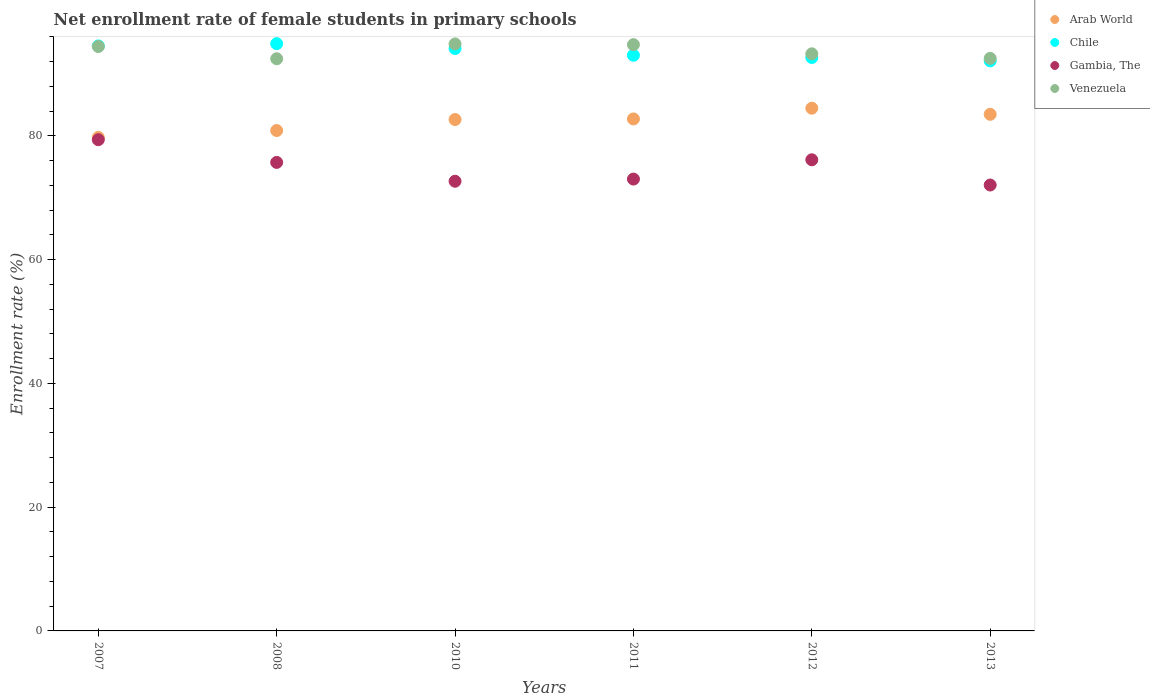How many different coloured dotlines are there?
Ensure brevity in your answer.  4. What is the net enrollment rate of female students in primary schools in Gambia, The in 2013?
Make the answer very short. 72.06. Across all years, what is the maximum net enrollment rate of female students in primary schools in Arab World?
Offer a very short reply. 84.48. Across all years, what is the minimum net enrollment rate of female students in primary schools in Arab World?
Ensure brevity in your answer.  79.76. What is the total net enrollment rate of female students in primary schools in Arab World in the graph?
Provide a short and direct response. 493.98. What is the difference between the net enrollment rate of female students in primary schools in Chile in 2011 and that in 2013?
Provide a succinct answer. 0.91. What is the difference between the net enrollment rate of female students in primary schools in Venezuela in 2011 and the net enrollment rate of female students in primary schools in Chile in 2012?
Your answer should be compact. 2.07. What is the average net enrollment rate of female students in primary schools in Venezuela per year?
Provide a short and direct response. 93.72. In the year 2011, what is the difference between the net enrollment rate of female students in primary schools in Arab World and net enrollment rate of female students in primary schools in Gambia, The?
Your response must be concise. 9.72. In how many years, is the net enrollment rate of female students in primary schools in Arab World greater than 72 %?
Provide a short and direct response. 6. What is the ratio of the net enrollment rate of female students in primary schools in Arab World in 2010 to that in 2012?
Provide a short and direct response. 0.98. What is the difference between the highest and the second highest net enrollment rate of female students in primary schools in Venezuela?
Offer a terse response. 0.12. What is the difference between the highest and the lowest net enrollment rate of female students in primary schools in Gambia, The?
Your response must be concise. 7.32. In how many years, is the net enrollment rate of female students in primary schools in Chile greater than the average net enrollment rate of female students in primary schools in Chile taken over all years?
Give a very brief answer. 3. Is it the case that in every year, the sum of the net enrollment rate of female students in primary schools in Gambia, The and net enrollment rate of female students in primary schools in Chile  is greater than the sum of net enrollment rate of female students in primary schools in Arab World and net enrollment rate of female students in primary schools in Venezuela?
Your answer should be compact. Yes. Is the net enrollment rate of female students in primary schools in Gambia, The strictly greater than the net enrollment rate of female students in primary schools in Arab World over the years?
Make the answer very short. No. How many dotlines are there?
Your answer should be very brief. 4. How many years are there in the graph?
Give a very brief answer. 6. What is the difference between two consecutive major ticks on the Y-axis?
Your response must be concise. 20. Does the graph contain grids?
Offer a terse response. No. Where does the legend appear in the graph?
Keep it short and to the point. Top right. How many legend labels are there?
Keep it short and to the point. 4. What is the title of the graph?
Keep it short and to the point. Net enrollment rate of female students in primary schools. What is the label or title of the Y-axis?
Your response must be concise. Enrollment rate (%). What is the Enrollment rate (%) in Arab World in 2007?
Offer a terse response. 79.76. What is the Enrollment rate (%) of Chile in 2007?
Your answer should be compact. 94.54. What is the Enrollment rate (%) of Gambia, The in 2007?
Offer a terse response. 79.38. What is the Enrollment rate (%) of Venezuela in 2007?
Your answer should be compact. 94.44. What is the Enrollment rate (%) of Arab World in 2008?
Offer a terse response. 80.87. What is the Enrollment rate (%) in Chile in 2008?
Your response must be concise. 94.91. What is the Enrollment rate (%) of Gambia, The in 2008?
Keep it short and to the point. 75.72. What is the Enrollment rate (%) in Venezuela in 2008?
Your answer should be very brief. 92.47. What is the Enrollment rate (%) of Arab World in 2010?
Your answer should be compact. 82.65. What is the Enrollment rate (%) of Chile in 2010?
Your response must be concise. 94.12. What is the Enrollment rate (%) of Gambia, The in 2010?
Offer a very short reply. 72.67. What is the Enrollment rate (%) of Venezuela in 2010?
Ensure brevity in your answer.  94.86. What is the Enrollment rate (%) in Arab World in 2011?
Your answer should be very brief. 82.74. What is the Enrollment rate (%) in Chile in 2011?
Your response must be concise. 93.03. What is the Enrollment rate (%) in Gambia, The in 2011?
Make the answer very short. 73.02. What is the Enrollment rate (%) of Venezuela in 2011?
Offer a very short reply. 94.74. What is the Enrollment rate (%) of Arab World in 2012?
Ensure brevity in your answer.  84.48. What is the Enrollment rate (%) of Chile in 2012?
Provide a succinct answer. 92.67. What is the Enrollment rate (%) in Gambia, The in 2012?
Give a very brief answer. 76.14. What is the Enrollment rate (%) in Venezuela in 2012?
Make the answer very short. 93.26. What is the Enrollment rate (%) in Arab World in 2013?
Give a very brief answer. 83.49. What is the Enrollment rate (%) of Chile in 2013?
Your answer should be compact. 92.12. What is the Enrollment rate (%) in Gambia, The in 2013?
Offer a very short reply. 72.06. What is the Enrollment rate (%) in Venezuela in 2013?
Your response must be concise. 92.53. Across all years, what is the maximum Enrollment rate (%) of Arab World?
Provide a succinct answer. 84.48. Across all years, what is the maximum Enrollment rate (%) of Chile?
Give a very brief answer. 94.91. Across all years, what is the maximum Enrollment rate (%) in Gambia, The?
Your answer should be compact. 79.38. Across all years, what is the maximum Enrollment rate (%) of Venezuela?
Offer a terse response. 94.86. Across all years, what is the minimum Enrollment rate (%) in Arab World?
Ensure brevity in your answer.  79.76. Across all years, what is the minimum Enrollment rate (%) in Chile?
Make the answer very short. 92.12. Across all years, what is the minimum Enrollment rate (%) in Gambia, The?
Give a very brief answer. 72.06. Across all years, what is the minimum Enrollment rate (%) of Venezuela?
Offer a very short reply. 92.47. What is the total Enrollment rate (%) in Arab World in the graph?
Ensure brevity in your answer.  493.98. What is the total Enrollment rate (%) in Chile in the graph?
Your response must be concise. 561.4. What is the total Enrollment rate (%) in Gambia, The in the graph?
Ensure brevity in your answer.  448.99. What is the total Enrollment rate (%) of Venezuela in the graph?
Ensure brevity in your answer.  562.31. What is the difference between the Enrollment rate (%) of Arab World in 2007 and that in 2008?
Give a very brief answer. -1.11. What is the difference between the Enrollment rate (%) in Chile in 2007 and that in 2008?
Ensure brevity in your answer.  -0.37. What is the difference between the Enrollment rate (%) of Gambia, The in 2007 and that in 2008?
Ensure brevity in your answer.  3.67. What is the difference between the Enrollment rate (%) in Venezuela in 2007 and that in 2008?
Provide a short and direct response. 1.98. What is the difference between the Enrollment rate (%) of Arab World in 2007 and that in 2010?
Make the answer very short. -2.89. What is the difference between the Enrollment rate (%) of Chile in 2007 and that in 2010?
Your answer should be compact. 0.41. What is the difference between the Enrollment rate (%) in Gambia, The in 2007 and that in 2010?
Offer a very short reply. 6.71. What is the difference between the Enrollment rate (%) of Venezuela in 2007 and that in 2010?
Your response must be concise. -0.42. What is the difference between the Enrollment rate (%) of Arab World in 2007 and that in 2011?
Your response must be concise. -2.98. What is the difference between the Enrollment rate (%) of Chile in 2007 and that in 2011?
Give a very brief answer. 1.51. What is the difference between the Enrollment rate (%) in Gambia, The in 2007 and that in 2011?
Offer a very short reply. 6.36. What is the difference between the Enrollment rate (%) of Venezuela in 2007 and that in 2011?
Your answer should be very brief. -0.3. What is the difference between the Enrollment rate (%) in Arab World in 2007 and that in 2012?
Keep it short and to the point. -4.72. What is the difference between the Enrollment rate (%) of Chile in 2007 and that in 2012?
Make the answer very short. 1.87. What is the difference between the Enrollment rate (%) of Gambia, The in 2007 and that in 2012?
Give a very brief answer. 3.24. What is the difference between the Enrollment rate (%) of Venezuela in 2007 and that in 2012?
Make the answer very short. 1.18. What is the difference between the Enrollment rate (%) in Arab World in 2007 and that in 2013?
Provide a succinct answer. -3.73. What is the difference between the Enrollment rate (%) of Chile in 2007 and that in 2013?
Offer a very short reply. 2.42. What is the difference between the Enrollment rate (%) in Gambia, The in 2007 and that in 2013?
Your response must be concise. 7.32. What is the difference between the Enrollment rate (%) of Venezuela in 2007 and that in 2013?
Ensure brevity in your answer.  1.91. What is the difference between the Enrollment rate (%) of Arab World in 2008 and that in 2010?
Your answer should be very brief. -1.78. What is the difference between the Enrollment rate (%) in Chile in 2008 and that in 2010?
Your response must be concise. 0.78. What is the difference between the Enrollment rate (%) of Gambia, The in 2008 and that in 2010?
Your response must be concise. 3.04. What is the difference between the Enrollment rate (%) in Venezuela in 2008 and that in 2010?
Your answer should be compact. -2.4. What is the difference between the Enrollment rate (%) of Arab World in 2008 and that in 2011?
Give a very brief answer. -1.87. What is the difference between the Enrollment rate (%) in Chile in 2008 and that in 2011?
Give a very brief answer. 1.88. What is the difference between the Enrollment rate (%) in Gambia, The in 2008 and that in 2011?
Keep it short and to the point. 2.69. What is the difference between the Enrollment rate (%) in Venezuela in 2008 and that in 2011?
Make the answer very short. -2.28. What is the difference between the Enrollment rate (%) in Arab World in 2008 and that in 2012?
Your answer should be compact. -3.61. What is the difference between the Enrollment rate (%) of Chile in 2008 and that in 2012?
Offer a terse response. 2.24. What is the difference between the Enrollment rate (%) in Gambia, The in 2008 and that in 2012?
Provide a succinct answer. -0.42. What is the difference between the Enrollment rate (%) in Venezuela in 2008 and that in 2012?
Offer a very short reply. -0.8. What is the difference between the Enrollment rate (%) of Arab World in 2008 and that in 2013?
Provide a succinct answer. -2.62. What is the difference between the Enrollment rate (%) in Chile in 2008 and that in 2013?
Keep it short and to the point. 2.78. What is the difference between the Enrollment rate (%) of Gambia, The in 2008 and that in 2013?
Offer a terse response. 3.65. What is the difference between the Enrollment rate (%) of Venezuela in 2008 and that in 2013?
Make the answer very short. -0.07. What is the difference between the Enrollment rate (%) of Arab World in 2010 and that in 2011?
Provide a short and direct response. -0.09. What is the difference between the Enrollment rate (%) of Chile in 2010 and that in 2011?
Give a very brief answer. 1.09. What is the difference between the Enrollment rate (%) of Gambia, The in 2010 and that in 2011?
Your answer should be compact. -0.35. What is the difference between the Enrollment rate (%) of Venezuela in 2010 and that in 2011?
Make the answer very short. 0.12. What is the difference between the Enrollment rate (%) in Arab World in 2010 and that in 2012?
Make the answer very short. -1.83. What is the difference between the Enrollment rate (%) of Chile in 2010 and that in 2012?
Offer a terse response. 1.45. What is the difference between the Enrollment rate (%) of Gambia, The in 2010 and that in 2012?
Keep it short and to the point. -3.47. What is the difference between the Enrollment rate (%) in Venezuela in 2010 and that in 2012?
Provide a short and direct response. 1.6. What is the difference between the Enrollment rate (%) of Arab World in 2010 and that in 2013?
Give a very brief answer. -0.84. What is the difference between the Enrollment rate (%) in Chile in 2010 and that in 2013?
Offer a very short reply. 2. What is the difference between the Enrollment rate (%) of Gambia, The in 2010 and that in 2013?
Offer a very short reply. 0.61. What is the difference between the Enrollment rate (%) of Venezuela in 2010 and that in 2013?
Ensure brevity in your answer.  2.33. What is the difference between the Enrollment rate (%) of Arab World in 2011 and that in 2012?
Offer a very short reply. -1.73. What is the difference between the Enrollment rate (%) in Chile in 2011 and that in 2012?
Make the answer very short. 0.36. What is the difference between the Enrollment rate (%) of Gambia, The in 2011 and that in 2012?
Ensure brevity in your answer.  -3.12. What is the difference between the Enrollment rate (%) of Venezuela in 2011 and that in 2012?
Offer a very short reply. 1.48. What is the difference between the Enrollment rate (%) of Arab World in 2011 and that in 2013?
Your answer should be compact. -0.75. What is the difference between the Enrollment rate (%) of Chile in 2011 and that in 2013?
Give a very brief answer. 0.91. What is the difference between the Enrollment rate (%) of Gambia, The in 2011 and that in 2013?
Provide a succinct answer. 0.96. What is the difference between the Enrollment rate (%) in Venezuela in 2011 and that in 2013?
Provide a short and direct response. 2.21. What is the difference between the Enrollment rate (%) in Arab World in 2012 and that in 2013?
Provide a succinct answer. 0.99. What is the difference between the Enrollment rate (%) of Chile in 2012 and that in 2013?
Offer a very short reply. 0.55. What is the difference between the Enrollment rate (%) of Gambia, The in 2012 and that in 2013?
Offer a very short reply. 4.08. What is the difference between the Enrollment rate (%) in Venezuela in 2012 and that in 2013?
Provide a short and direct response. 0.73. What is the difference between the Enrollment rate (%) of Arab World in 2007 and the Enrollment rate (%) of Chile in 2008?
Make the answer very short. -15.15. What is the difference between the Enrollment rate (%) of Arab World in 2007 and the Enrollment rate (%) of Gambia, The in 2008?
Give a very brief answer. 4.04. What is the difference between the Enrollment rate (%) of Arab World in 2007 and the Enrollment rate (%) of Venezuela in 2008?
Provide a short and direct response. -12.71. What is the difference between the Enrollment rate (%) of Chile in 2007 and the Enrollment rate (%) of Gambia, The in 2008?
Your response must be concise. 18.82. What is the difference between the Enrollment rate (%) of Chile in 2007 and the Enrollment rate (%) of Venezuela in 2008?
Provide a short and direct response. 2.07. What is the difference between the Enrollment rate (%) in Gambia, The in 2007 and the Enrollment rate (%) in Venezuela in 2008?
Your response must be concise. -13.08. What is the difference between the Enrollment rate (%) of Arab World in 2007 and the Enrollment rate (%) of Chile in 2010?
Ensure brevity in your answer.  -14.37. What is the difference between the Enrollment rate (%) of Arab World in 2007 and the Enrollment rate (%) of Gambia, The in 2010?
Give a very brief answer. 7.09. What is the difference between the Enrollment rate (%) of Arab World in 2007 and the Enrollment rate (%) of Venezuela in 2010?
Your answer should be very brief. -15.1. What is the difference between the Enrollment rate (%) of Chile in 2007 and the Enrollment rate (%) of Gambia, The in 2010?
Ensure brevity in your answer.  21.87. What is the difference between the Enrollment rate (%) of Chile in 2007 and the Enrollment rate (%) of Venezuela in 2010?
Your response must be concise. -0.32. What is the difference between the Enrollment rate (%) of Gambia, The in 2007 and the Enrollment rate (%) of Venezuela in 2010?
Provide a short and direct response. -15.48. What is the difference between the Enrollment rate (%) of Arab World in 2007 and the Enrollment rate (%) of Chile in 2011?
Your response must be concise. -13.27. What is the difference between the Enrollment rate (%) of Arab World in 2007 and the Enrollment rate (%) of Gambia, The in 2011?
Offer a terse response. 6.74. What is the difference between the Enrollment rate (%) of Arab World in 2007 and the Enrollment rate (%) of Venezuela in 2011?
Your answer should be compact. -14.99. What is the difference between the Enrollment rate (%) in Chile in 2007 and the Enrollment rate (%) in Gambia, The in 2011?
Provide a short and direct response. 21.52. What is the difference between the Enrollment rate (%) of Chile in 2007 and the Enrollment rate (%) of Venezuela in 2011?
Offer a very short reply. -0.21. What is the difference between the Enrollment rate (%) in Gambia, The in 2007 and the Enrollment rate (%) in Venezuela in 2011?
Ensure brevity in your answer.  -15.36. What is the difference between the Enrollment rate (%) in Arab World in 2007 and the Enrollment rate (%) in Chile in 2012?
Your response must be concise. -12.91. What is the difference between the Enrollment rate (%) of Arab World in 2007 and the Enrollment rate (%) of Gambia, The in 2012?
Your answer should be compact. 3.62. What is the difference between the Enrollment rate (%) of Arab World in 2007 and the Enrollment rate (%) of Venezuela in 2012?
Offer a very short reply. -13.5. What is the difference between the Enrollment rate (%) of Chile in 2007 and the Enrollment rate (%) of Gambia, The in 2012?
Give a very brief answer. 18.4. What is the difference between the Enrollment rate (%) of Chile in 2007 and the Enrollment rate (%) of Venezuela in 2012?
Your response must be concise. 1.28. What is the difference between the Enrollment rate (%) of Gambia, The in 2007 and the Enrollment rate (%) of Venezuela in 2012?
Give a very brief answer. -13.88. What is the difference between the Enrollment rate (%) in Arab World in 2007 and the Enrollment rate (%) in Chile in 2013?
Give a very brief answer. -12.36. What is the difference between the Enrollment rate (%) of Arab World in 2007 and the Enrollment rate (%) of Gambia, The in 2013?
Ensure brevity in your answer.  7.7. What is the difference between the Enrollment rate (%) in Arab World in 2007 and the Enrollment rate (%) in Venezuela in 2013?
Your response must be concise. -12.77. What is the difference between the Enrollment rate (%) in Chile in 2007 and the Enrollment rate (%) in Gambia, The in 2013?
Your answer should be very brief. 22.48. What is the difference between the Enrollment rate (%) of Chile in 2007 and the Enrollment rate (%) of Venezuela in 2013?
Provide a short and direct response. 2.01. What is the difference between the Enrollment rate (%) in Gambia, The in 2007 and the Enrollment rate (%) in Venezuela in 2013?
Provide a succinct answer. -13.15. What is the difference between the Enrollment rate (%) of Arab World in 2008 and the Enrollment rate (%) of Chile in 2010?
Offer a very short reply. -13.26. What is the difference between the Enrollment rate (%) of Arab World in 2008 and the Enrollment rate (%) of Gambia, The in 2010?
Offer a terse response. 8.2. What is the difference between the Enrollment rate (%) of Arab World in 2008 and the Enrollment rate (%) of Venezuela in 2010?
Provide a short and direct response. -14. What is the difference between the Enrollment rate (%) of Chile in 2008 and the Enrollment rate (%) of Gambia, The in 2010?
Keep it short and to the point. 22.24. What is the difference between the Enrollment rate (%) in Chile in 2008 and the Enrollment rate (%) in Venezuela in 2010?
Provide a short and direct response. 0.04. What is the difference between the Enrollment rate (%) of Gambia, The in 2008 and the Enrollment rate (%) of Venezuela in 2010?
Your answer should be very brief. -19.15. What is the difference between the Enrollment rate (%) in Arab World in 2008 and the Enrollment rate (%) in Chile in 2011?
Give a very brief answer. -12.17. What is the difference between the Enrollment rate (%) of Arab World in 2008 and the Enrollment rate (%) of Gambia, The in 2011?
Make the answer very short. 7.84. What is the difference between the Enrollment rate (%) of Arab World in 2008 and the Enrollment rate (%) of Venezuela in 2011?
Give a very brief answer. -13.88. What is the difference between the Enrollment rate (%) in Chile in 2008 and the Enrollment rate (%) in Gambia, The in 2011?
Keep it short and to the point. 21.89. What is the difference between the Enrollment rate (%) of Chile in 2008 and the Enrollment rate (%) of Venezuela in 2011?
Your response must be concise. 0.16. What is the difference between the Enrollment rate (%) of Gambia, The in 2008 and the Enrollment rate (%) of Venezuela in 2011?
Your response must be concise. -19.03. What is the difference between the Enrollment rate (%) in Arab World in 2008 and the Enrollment rate (%) in Chile in 2012?
Offer a very short reply. -11.8. What is the difference between the Enrollment rate (%) in Arab World in 2008 and the Enrollment rate (%) in Gambia, The in 2012?
Keep it short and to the point. 4.73. What is the difference between the Enrollment rate (%) in Arab World in 2008 and the Enrollment rate (%) in Venezuela in 2012?
Give a very brief answer. -12.4. What is the difference between the Enrollment rate (%) in Chile in 2008 and the Enrollment rate (%) in Gambia, The in 2012?
Give a very brief answer. 18.77. What is the difference between the Enrollment rate (%) in Chile in 2008 and the Enrollment rate (%) in Venezuela in 2012?
Provide a short and direct response. 1.65. What is the difference between the Enrollment rate (%) of Gambia, The in 2008 and the Enrollment rate (%) of Venezuela in 2012?
Your response must be concise. -17.55. What is the difference between the Enrollment rate (%) of Arab World in 2008 and the Enrollment rate (%) of Chile in 2013?
Your answer should be compact. -11.26. What is the difference between the Enrollment rate (%) in Arab World in 2008 and the Enrollment rate (%) in Gambia, The in 2013?
Offer a very short reply. 8.81. What is the difference between the Enrollment rate (%) in Arab World in 2008 and the Enrollment rate (%) in Venezuela in 2013?
Ensure brevity in your answer.  -11.66. What is the difference between the Enrollment rate (%) of Chile in 2008 and the Enrollment rate (%) of Gambia, The in 2013?
Keep it short and to the point. 22.85. What is the difference between the Enrollment rate (%) in Chile in 2008 and the Enrollment rate (%) in Venezuela in 2013?
Offer a very short reply. 2.38. What is the difference between the Enrollment rate (%) of Gambia, The in 2008 and the Enrollment rate (%) of Venezuela in 2013?
Your answer should be very brief. -16.82. What is the difference between the Enrollment rate (%) in Arab World in 2010 and the Enrollment rate (%) in Chile in 2011?
Make the answer very short. -10.39. What is the difference between the Enrollment rate (%) of Arab World in 2010 and the Enrollment rate (%) of Gambia, The in 2011?
Your answer should be very brief. 9.62. What is the difference between the Enrollment rate (%) in Arab World in 2010 and the Enrollment rate (%) in Venezuela in 2011?
Make the answer very short. -12.1. What is the difference between the Enrollment rate (%) in Chile in 2010 and the Enrollment rate (%) in Gambia, The in 2011?
Offer a terse response. 21.1. What is the difference between the Enrollment rate (%) in Chile in 2010 and the Enrollment rate (%) in Venezuela in 2011?
Ensure brevity in your answer.  -0.62. What is the difference between the Enrollment rate (%) of Gambia, The in 2010 and the Enrollment rate (%) of Venezuela in 2011?
Make the answer very short. -22.07. What is the difference between the Enrollment rate (%) in Arab World in 2010 and the Enrollment rate (%) in Chile in 2012?
Offer a terse response. -10.03. What is the difference between the Enrollment rate (%) of Arab World in 2010 and the Enrollment rate (%) of Gambia, The in 2012?
Your response must be concise. 6.51. What is the difference between the Enrollment rate (%) in Arab World in 2010 and the Enrollment rate (%) in Venezuela in 2012?
Keep it short and to the point. -10.62. What is the difference between the Enrollment rate (%) in Chile in 2010 and the Enrollment rate (%) in Gambia, The in 2012?
Make the answer very short. 17.99. What is the difference between the Enrollment rate (%) of Chile in 2010 and the Enrollment rate (%) of Venezuela in 2012?
Make the answer very short. 0.86. What is the difference between the Enrollment rate (%) of Gambia, The in 2010 and the Enrollment rate (%) of Venezuela in 2012?
Offer a very short reply. -20.59. What is the difference between the Enrollment rate (%) in Arab World in 2010 and the Enrollment rate (%) in Chile in 2013?
Provide a short and direct response. -9.48. What is the difference between the Enrollment rate (%) in Arab World in 2010 and the Enrollment rate (%) in Gambia, The in 2013?
Offer a terse response. 10.59. What is the difference between the Enrollment rate (%) of Arab World in 2010 and the Enrollment rate (%) of Venezuela in 2013?
Provide a succinct answer. -9.88. What is the difference between the Enrollment rate (%) in Chile in 2010 and the Enrollment rate (%) in Gambia, The in 2013?
Give a very brief answer. 22.06. What is the difference between the Enrollment rate (%) of Chile in 2010 and the Enrollment rate (%) of Venezuela in 2013?
Make the answer very short. 1.59. What is the difference between the Enrollment rate (%) in Gambia, The in 2010 and the Enrollment rate (%) in Venezuela in 2013?
Your answer should be very brief. -19.86. What is the difference between the Enrollment rate (%) of Arab World in 2011 and the Enrollment rate (%) of Chile in 2012?
Your response must be concise. -9.93. What is the difference between the Enrollment rate (%) in Arab World in 2011 and the Enrollment rate (%) in Gambia, The in 2012?
Your answer should be very brief. 6.6. What is the difference between the Enrollment rate (%) in Arab World in 2011 and the Enrollment rate (%) in Venezuela in 2012?
Your answer should be very brief. -10.52. What is the difference between the Enrollment rate (%) in Chile in 2011 and the Enrollment rate (%) in Gambia, The in 2012?
Your response must be concise. 16.89. What is the difference between the Enrollment rate (%) in Chile in 2011 and the Enrollment rate (%) in Venezuela in 2012?
Make the answer very short. -0.23. What is the difference between the Enrollment rate (%) in Gambia, The in 2011 and the Enrollment rate (%) in Venezuela in 2012?
Your answer should be very brief. -20.24. What is the difference between the Enrollment rate (%) in Arab World in 2011 and the Enrollment rate (%) in Chile in 2013?
Provide a short and direct response. -9.38. What is the difference between the Enrollment rate (%) of Arab World in 2011 and the Enrollment rate (%) of Gambia, The in 2013?
Keep it short and to the point. 10.68. What is the difference between the Enrollment rate (%) in Arab World in 2011 and the Enrollment rate (%) in Venezuela in 2013?
Provide a succinct answer. -9.79. What is the difference between the Enrollment rate (%) of Chile in 2011 and the Enrollment rate (%) of Gambia, The in 2013?
Offer a very short reply. 20.97. What is the difference between the Enrollment rate (%) of Chile in 2011 and the Enrollment rate (%) of Venezuela in 2013?
Make the answer very short. 0.5. What is the difference between the Enrollment rate (%) of Gambia, The in 2011 and the Enrollment rate (%) of Venezuela in 2013?
Your response must be concise. -19.51. What is the difference between the Enrollment rate (%) of Arab World in 2012 and the Enrollment rate (%) of Chile in 2013?
Ensure brevity in your answer.  -7.65. What is the difference between the Enrollment rate (%) in Arab World in 2012 and the Enrollment rate (%) in Gambia, The in 2013?
Provide a short and direct response. 12.41. What is the difference between the Enrollment rate (%) in Arab World in 2012 and the Enrollment rate (%) in Venezuela in 2013?
Keep it short and to the point. -8.06. What is the difference between the Enrollment rate (%) of Chile in 2012 and the Enrollment rate (%) of Gambia, The in 2013?
Provide a succinct answer. 20.61. What is the difference between the Enrollment rate (%) in Chile in 2012 and the Enrollment rate (%) in Venezuela in 2013?
Provide a succinct answer. 0.14. What is the difference between the Enrollment rate (%) in Gambia, The in 2012 and the Enrollment rate (%) in Venezuela in 2013?
Your response must be concise. -16.39. What is the average Enrollment rate (%) of Arab World per year?
Make the answer very short. 82.33. What is the average Enrollment rate (%) in Chile per year?
Give a very brief answer. 93.57. What is the average Enrollment rate (%) in Gambia, The per year?
Provide a succinct answer. 74.83. What is the average Enrollment rate (%) in Venezuela per year?
Offer a very short reply. 93.72. In the year 2007, what is the difference between the Enrollment rate (%) of Arab World and Enrollment rate (%) of Chile?
Provide a succinct answer. -14.78. In the year 2007, what is the difference between the Enrollment rate (%) of Arab World and Enrollment rate (%) of Gambia, The?
Give a very brief answer. 0.38. In the year 2007, what is the difference between the Enrollment rate (%) of Arab World and Enrollment rate (%) of Venezuela?
Offer a very short reply. -14.68. In the year 2007, what is the difference between the Enrollment rate (%) in Chile and Enrollment rate (%) in Gambia, The?
Offer a terse response. 15.16. In the year 2007, what is the difference between the Enrollment rate (%) in Chile and Enrollment rate (%) in Venezuela?
Keep it short and to the point. 0.1. In the year 2007, what is the difference between the Enrollment rate (%) of Gambia, The and Enrollment rate (%) of Venezuela?
Provide a short and direct response. -15.06. In the year 2008, what is the difference between the Enrollment rate (%) in Arab World and Enrollment rate (%) in Chile?
Your answer should be very brief. -14.04. In the year 2008, what is the difference between the Enrollment rate (%) in Arab World and Enrollment rate (%) in Gambia, The?
Ensure brevity in your answer.  5.15. In the year 2008, what is the difference between the Enrollment rate (%) of Arab World and Enrollment rate (%) of Venezuela?
Offer a very short reply. -11.6. In the year 2008, what is the difference between the Enrollment rate (%) of Chile and Enrollment rate (%) of Gambia, The?
Your answer should be compact. 19.19. In the year 2008, what is the difference between the Enrollment rate (%) of Chile and Enrollment rate (%) of Venezuela?
Make the answer very short. 2.44. In the year 2008, what is the difference between the Enrollment rate (%) of Gambia, The and Enrollment rate (%) of Venezuela?
Give a very brief answer. -16.75. In the year 2010, what is the difference between the Enrollment rate (%) of Arab World and Enrollment rate (%) of Chile?
Make the answer very short. -11.48. In the year 2010, what is the difference between the Enrollment rate (%) of Arab World and Enrollment rate (%) of Gambia, The?
Your answer should be very brief. 9.98. In the year 2010, what is the difference between the Enrollment rate (%) of Arab World and Enrollment rate (%) of Venezuela?
Keep it short and to the point. -12.22. In the year 2010, what is the difference between the Enrollment rate (%) of Chile and Enrollment rate (%) of Gambia, The?
Offer a terse response. 21.45. In the year 2010, what is the difference between the Enrollment rate (%) in Chile and Enrollment rate (%) in Venezuela?
Your answer should be very brief. -0.74. In the year 2010, what is the difference between the Enrollment rate (%) in Gambia, The and Enrollment rate (%) in Venezuela?
Give a very brief answer. -22.19. In the year 2011, what is the difference between the Enrollment rate (%) of Arab World and Enrollment rate (%) of Chile?
Provide a succinct answer. -10.29. In the year 2011, what is the difference between the Enrollment rate (%) of Arab World and Enrollment rate (%) of Gambia, The?
Give a very brief answer. 9.72. In the year 2011, what is the difference between the Enrollment rate (%) of Arab World and Enrollment rate (%) of Venezuela?
Ensure brevity in your answer.  -12. In the year 2011, what is the difference between the Enrollment rate (%) in Chile and Enrollment rate (%) in Gambia, The?
Give a very brief answer. 20.01. In the year 2011, what is the difference between the Enrollment rate (%) of Chile and Enrollment rate (%) of Venezuela?
Provide a short and direct response. -1.71. In the year 2011, what is the difference between the Enrollment rate (%) in Gambia, The and Enrollment rate (%) in Venezuela?
Offer a terse response. -21.72. In the year 2012, what is the difference between the Enrollment rate (%) in Arab World and Enrollment rate (%) in Chile?
Provide a short and direct response. -8.2. In the year 2012, what is the difference between the Enrollment rate (%) in Arab World and Enrollment rate (%) in Gambia, The?
Your answer should be very brief. 8.34. In the year 2012, what is the difference between the Enrollment rate (%) of Arab World and Enrollment rate (%) of Venezuela?
Provide a succinct answer. -8.79. In the year 2012, what is the difference between the Enrollment rate (%) of Chile and Enrollment rate (%) of Gambia, The?
Provide a succinct answer. 16.53. In the year 2012, what is the difference between the Enrollment rate (%) of Chile and Enrollment rate (%) of Venezuela?
Your answer should be compact. -0.59. In the year 2012, what is the difference between the Enrollment rate (%) in Gambia, The and Enrollment rate (%) in Venezuela?
Provide a short and direct response. -17.12. In the year 2013, what is the difference between the Enrollment rate (%) in Arab World and Enrollment rate (%) in Chile?
Give a very brief answer. -8.64. In the year 2013, what is the difference between the Enrollment rate (%) in Arab World and Enrollment rate (%) in Gambia, The?
Offer a very short reply. 11.43. In the year 2013, what is the difference between the Enrollment rate (%) in Arab World and Enrollment rate (%) in Venezuela?
Your response must be concise. -9.04. In the year 2013, what is the difference between the Enrollment rate (%) in Chile and Enrollment rate (%) in Gambia, The?
Your answer should be compact. 20.06. In the year 2013, what is the difference between the Enrollment rate (%) in Chile and Enrollment rate (%) in Venezuela?
Keep it short and to the point. -0.41. In the year 2013, what is the difference between the Enrollment rate (%) in Gambia, The and Enrollment rate (%) in Venezuela?
Provide a short and direct response. -20.47. What is the ratio of the Enrollment rate (%) in Arab World in 2007 to that in 2008?
Your response must be concise. 0.99. What is the ratio of the Enrollment rate (%) of Chile in 2007 to that in 2008?
Provide a short and direct response. 1. What is the ratio of the Enrollment rate (%) in Gambia, The in 2007 to that in 2008?
Give a very brief answer. 1.05. What is the ratio of the Enrollment rate (%) in Venezuela in 2007 to that in 2008?
Your answer should be compact. 1.02. What is the ratio of the Enrollment rate (%) of Arab World in 2007 to that in 2010?
Provide a succinct answer. 0.97. What is the ratio of the Enrollment rate (%) in Chile in 2007 to that in 2010?
Give a very brief answer. 1. What is the ratio of the Enrollment rate (%) of Gambia, The in 2007 to that in 2010?
Your answer should be compact. 1.09. What is the ratio of the Enrollment rate (%) in Arab World in 2007 to that in 2011?
Your answer should be compact. 0.96. What is the ratio of the Enrollment rate (%) in Chile in 2007 to that in 2011?
Give a very brief answer. 1.02. What is the ratio of the Enrollment rate (%) of Gambia, The in 2007 to that in 2011?
Offer a very short reply. 1.09. What is the ratio of the Enrollment rate (%) of Arab World in 2007 to that in 2012?
Provide a succinct answer. 0.94. What is the ratio of the Enrollment rate (%) of Chile in 2007 to that in 2012?
Keep it short and to the point. 1.02. What is the ratio of the Enrollment rate (%) of Gambia, The in 2007 to that in 2012?
Give a very brief answer. 1.04. What is the ratio of the Enrollment rate (%) of Venezuela in 2007 to that in 2012?
Your answer should be very brief. 1.01. What is the ratio of the Enrollment rate (%) in Arab World in 2007 to that in 2013?
Offer a terse response. 0.96. What is the ratio of the Enrollment rate (%) of Chile in 2007 to that in 2013?
Offer a very short reply. 1.03. What is the ratio of the Enrollment rate (%) of Gambia, The in 2007 to that in 2013?
Give a very brief answer. 1.1. What is the ratio of the Enrollment rate (%) in Venezuela in 2007 to that in 2013?
Your answer should be compact. 1.02. What is the ratio of the Enrollment rate (%) in Arab World in 2008 to that in 2010?
Your answer should be compact. 0.98. What is the ratio of the Enrollment rate (%) of Chile in 2008 to that in 2010?
Offer a terse response. 1.01. What is the ratio of the Enrollment rate (%) of Gambia, The in 2008 to that in 2010?
Offer a very short reply. 1.04. What is the ratio of the Enrollment rate (%) of Venezuela in 2008 to that in 2010?
Ensure brevity in your answer.  0.97. What is the ratio of the Enrollment rate (%) of Arab World in 2008 to that in 2011?
Offer a very short reply. 0.98. What is the ratio of the Enrollment rate (%) of Chile in 2008 to that in 2011?
Your response must be concise. 1.02. What is the ratio of the Enrollment rate (%) in Gambia, The in 2008 to that in 2011?
Ensure brevity in your answer.  1.04. What is the ratio of the Enrollment rate (%) of Arab World in 2008 to that in 2012?
Provide a short and direct response. 0.96. What is the ratio of the Enrollment rate (%) of Chile in 2008 to that in 2012?
Offer a very short reply. 1.02. What is the ratio of the Enrollment rate (%) in Gambia, The in 2008 to that in 2012?
Your answer should be compact. 0.99. What is the ratio of the Enrollment rate (%) of Arab World in 2008 to that in 2013?
Make the answer very short. 0.97. What is the ratio of the Enrollment rate (%) of Chile in 2008 to that in 2013?
Offer a terse response. 1.03. What is the ratio of the Enrollment rate (%) in Gambia, The in 2008 to that in 2013?
Your answer should be very brief. 1.05. What is the ratio of the Enrollment rate (%) in Venezuela in 2008 to that in 2013?
Your answer should be compact. 1. What is the ratio of the Enrollment rate (%) in Arab World in 2010 to that in 2011?
Keep it short and to the point. 1. What is the ratio of the Enrollment rate (%) in Chile in 2010 to that in 2011?
Offer a terse response. 1.01. What is the ratio of the Enrollment rate (%) of Arab World in 2010 to that in 2012?
Offer a terse response. 0.98. What is the ratio of the Enrollment rate (%) in Chile in 2010 to that in 2012?
Your response must be concise. 1.02. What is the ratio of the Enrollment rate (%) of Gambia, The in 2010 to that in 2012?
Keep it short and to the point. 0.95. What is the ratio of the Enrollment rate (%) in Venezuela in 2010 to that in 2012?
Your answer should be very brief. 1.02. What is the ratio of the Enrollment rate (%) in Arab World in 2010 to that in 2013?
Give a very brief answer. 0.99. What is the ratio of the Enrollment rate (%) of Chile in 2010 to that in 2013?
Your answer should be very brief. 1.02. What is the ratio of the Enrollment rate (%) in Gambia, The in 2010 to that in 2013?
Provide a succinct answer. 1.01. What is the ratio of the Enrollment rate (%) in Venezuela in 2010 to that in 2013?
Offer a very short reply. 1.03. What is the ratio of the Enrollment rate (%) in Arab World in 2011 to that in 2012?
Provide a short and direct response. 0.98. What is the ratio of the Enrollment rate (%) of Gambia, The in 2011 to that in 2012?
Your answer should be very brief. 0.96. What is the ratio of the Enrollment rate (%) of Venezuela in 2011 to that in 2012?
Your answer should be very brief. 1.02. What is the ratio of the Enrollment rate (%) in Chile in 2011 to that in 2013?
Offer a very short reply. 1.01. What is the ratio of the Enrollment rate (%) in Gambia, The in 2011 to that in 2013?
Offer a terse response. 1.01. What is the ratio of the Enrollment rate (%) of Venezuela in 2011 to that in 2013?
Your answer should be compact. 1.02. What is the ratio of the Enrollment rate (%) in Arab World in 2012 to that in 2013?
Offer a very short reply. 1.01. What is the ratio of the Enrollment rate (%) in Chile in 2012 to that in 2013?
Give a very brief answer. 1.01. What is the ratio of the Enrollment rate (%) of Gambia, The in 2012 to that in 2013?
Offer a very short reply. 1.06. What is the ratio of the Enrollment rate (%) of Venezuela in 2012 to that in 2013?
Your response must be concise. 1.01. What is the difference between the highest and the second highest Enrollment rate (%) of Arab World?
Your answer should be compact. 0.99. What is the difference between the highest and the second highest Enrollment rate (%) in Chile?
Make the answer very short. 0.37. What is the difference between the highest and the second highest Enrollment rate (%) of Gambia, The?
Provide a succinct answer. 3.24. What is the difference between the highest and the second highest Enrollment rate (%) of Venezuela?
Your answer should be compact. 0.12. What is the difference between the highest and the lowest Enrollment rate (%) of Arab World?
Provide a succinct answer. 4.72. What is the difference between the highest and the lowest Enrollment rate (%) of Chile?
Your response must be concise. 2.78. What is the difference between the highest and the lowest Enrollment rate (%) of Gambia, The?
Your answer should be compact. 7.32. What is the difference between the highest and the lowest Enrollment rate (%) in Venezuela?
Provide a succinct answer. 2.4. 